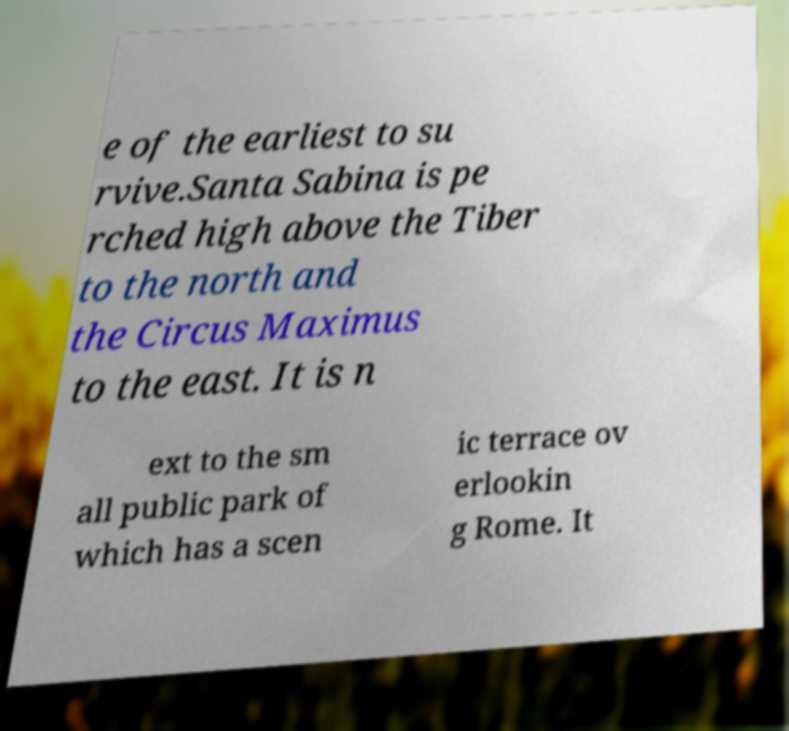Could you assist in decoding the text presented in this image and type it out clearly? e of the earliest to su rvive.Santa Sabina is pe rched high above the Tiber to the north and the Circus Maximus to the east. It is n ext to the sm all public park of which has a scen ic terrace ov erlookin g Rome. It 